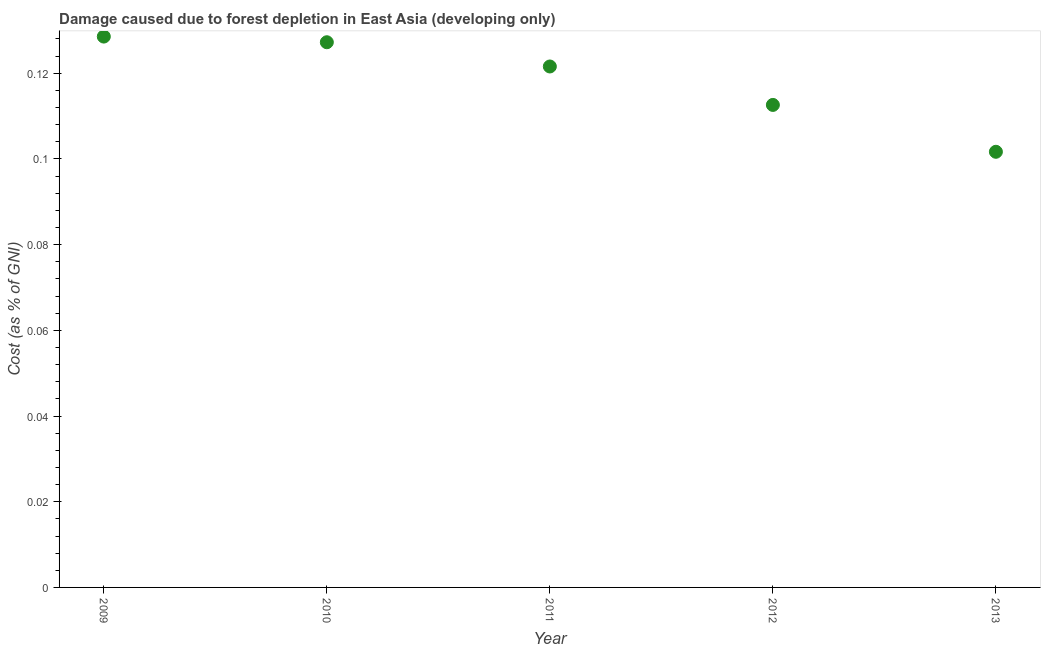What is the damage caused due to forest depletion in 2012?
Provide a short and direct response. 0.11. Across all years, what is the maximum damage caused due to forest depletion?
Give a very brief answer. 0.13. Across all years, what is the minimum damage caused due to forest depletion?
Your answer should be compact. 0.1. In which year was the damage caused due to forest depletion maximum?
Offer a very short reply. 2009. In which year was the damage caused due to forest depletion minimum?
Your response must be concise. 2013. What is the sum of the damage caused due to forest depletion?
Give a very brief answer. 0.59. What is the difference between the damage caused due to forest depletion in 2012 and 2013?
Ensure brevity in your answer.  0.01. What is the average damage caused due to forest depletion per year?
Provide a short and direct response. 0.12. What is the median damage caused due to forest depletion?
Offer a terse response. 0.12. What is the ratio of the damage caused due to forest depletion in 2009 to that in 2012?
Give a very brief answer. 1.14. Is the damage caused due to forest depletion in 2009 less than that in 2012?
Provide a short and direct response. No. What is the difference between the highest and the second highest damage caused due to forest depletion?
Make the answer very short. 0. What is the difference between the highest and the lowest damage caused due to forest depletion?
Make the answer very short. 0.03. In how many years, is the damage caused due to forest depletion greater than the average damage caused due to forest depletion taken over all years?
Keep it short and to the point. 3. How many dotlines are there?
Your response must be concise. 1. How many years are there in the graph?
Offer a terse response. 5. Does the graph contain any zero values?
Provide a succinct answer. No. What is the title of the graph?
Make the answer very short. Damage caused due to forest depletion in East Asia (developing only). What is the label or title of the X-axis?
Your response must be concise. Year. What is the label or title of the Y-axis?
Your answer should be very brief. Cost (as % of GNI). What is the Cost (as % of GNI) in 2009?
Ensure brevity in your answer.  0.13. What is the Cost (as % of GNI) in 2010?
Your answer should be compact. 0.13. What is the Cost (as % of GNI) in 2011?
Your answer should be compact. 0.12. What is the Cost (as % of GNI) in 2012?
Offer a very short reply. 0.11. What is the Cost (as % of GNI) in 2013?
Ensure brevity in your answer.  0.1. What is the difference between the Cost (as % of GNI) in 2009 and 2010?
Make the answer very short. 0. What is the difference between the Cost (as % of GNI) in 2009 and 2011?
Give a very brief answer. 0.01. What is the difference between the Cost (as % of GNI) in 2009 and 2012?
Your response must be concise. 0.02. What is the difference between the Cost (as % of GNI) in 2009 and 2013?
Keep it short and to the point. 0.03. What is the difference between the Cost (as % of GNI) in 2010 and 2011?
Provide a succinct answer. 0.01. What is the difference between the Cost (as % of GNI) in 2010 and 2012?
Your response must be concise. 0.01. What is the difference between the Cost (as % of GNI) in 2010 and 2013?
Give a very brief answer. 0.03. What is the difference between the Cost (as % of GNI) in 2011 and 2012?
Make the answer very short. 0.01. What is the difference between the Cost (as % of GNI) in 2011 and 2013?
Make the answer very short. 0.02. What is the difference between the Cost (as % of GNI) in 2012 and 2013?
Your answer should be very brief. 0.01. What is the ratio of the Cost (as % of GNI) in 2009 to that in 2010?
Your answer should be very brief. 1.01. What is the ratio of the Cost (as % of GNI) in 2009 to that in 2011?
Provide a succinct answer. 1.06. What is the ratio of the Cost (as % of GNI) in 2009 to that in 2012?
Your answer should be compact. 1.14. What is the ratio of the Cost (as % of GNI) in 2009 to that in 2013?
Ensure brevity in your answer.  1.26. What is the ratio of the Cost (as % of GNI) in 2010 to that in 2011?
Ensure brevity in your answer.  1.05. What is the ratio of the Cost (as % of GNI) in 2010 to that in 2012?
Make the answer very short. 1.13. What is the ratio of the Cost (as % of GNI) in 2010 to that in 2013?
Your answer should be very brief. 1.25. What is the ratio of the Cost (as % of GNI) in 2011 to that in 2012?
Provide a succinct answer. 1.08. What is the ratio of the Cost (as % of GNI) in 2011 to that in 2013?
Provide a short and direct response. 1.2. What is the ratio of the Cost (as % of GNI) in 2012 to that in 2013?
Ensure brevity in your answer.  1.11. 